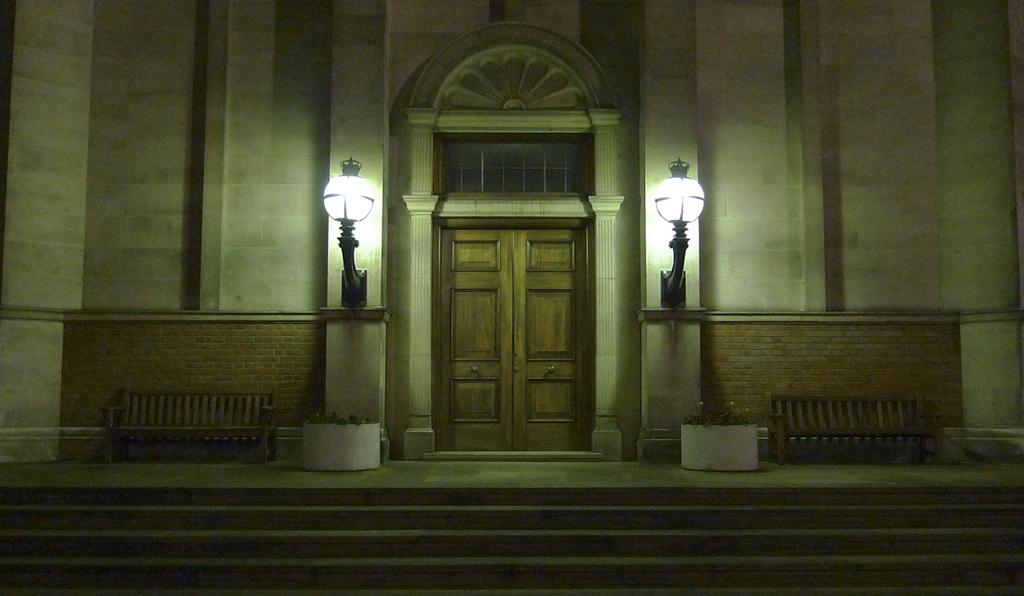What type of structure can be seen in the image? There is a building in the image. What are the lighting fixtures in the image? There are two lamps on the wall. What is a feature of the building that allows access? There is a door in the image. What type of seating is present in the image? There are benches in the image. What architectural element is present for vertical movement? There is a staircase in the image. What type of committee is meeting in the image? There is no committee meeting in the image; it only shows a building with various features. Can you see any goldfish swimming in the image? There are no goldfish present in the image. 